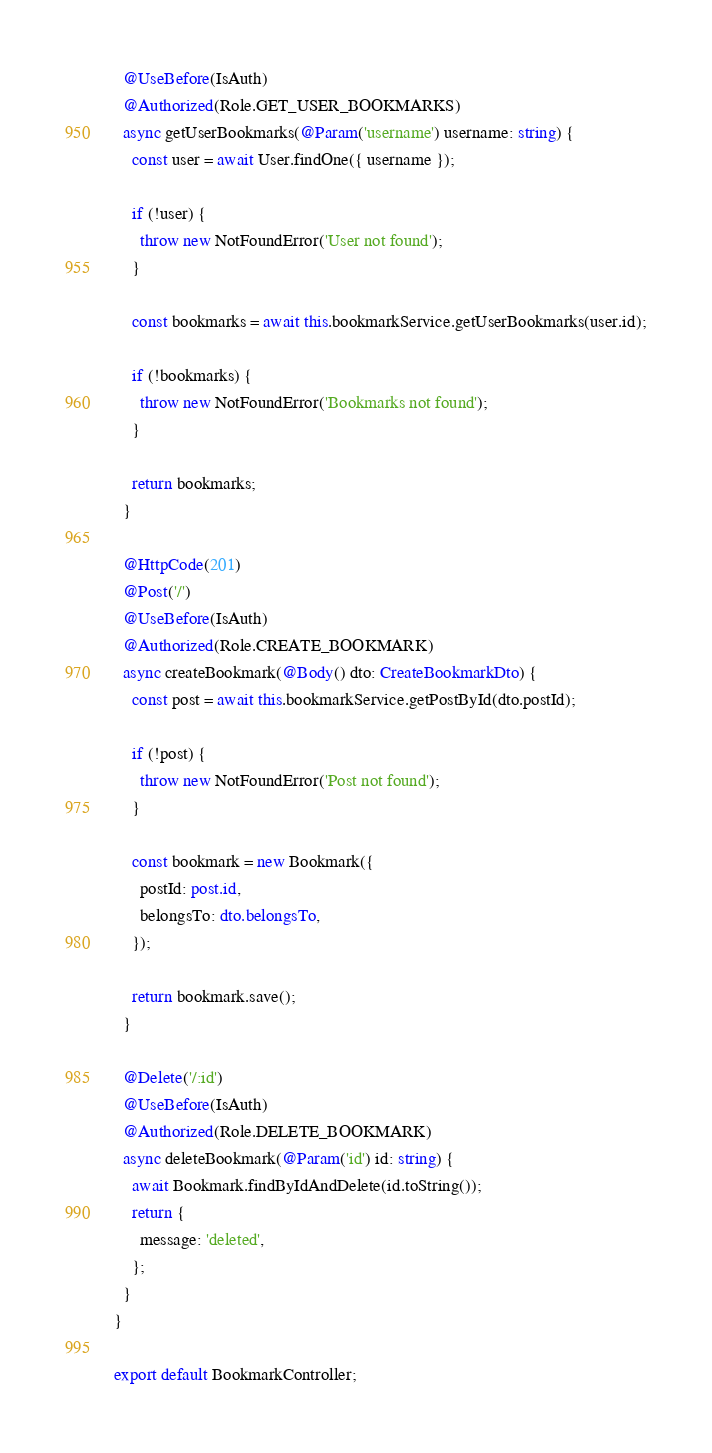<code> <loc_0><loc_0><loc_500><loc_500><_TypeScript_>  @UseBefore(IsAuth)
  @Authorized(Role.GET_USER_BOOKMARKS)
  async getUserBookmarks(@Param('username') username: string) {
    const user = await User.findOne({ username });

    if (!user) {
      throw new NotFoundError('User not found');
    }

    const bookmarks = await this.bookmarkService.getUserBookmarks(user.id);

    if (!bookmarks) {
      throw new NotFoundError('Bookmarks not found');
    }

    return bookmarks;
  }

  @HttpCode(201)
  @Post('/')
  @UseBefore(IsAuth)
  @Authorized(Role.CREATE_BOOKMARK)
  async createBookmark(@Body() dto: CreateBookmarkDto) {
    const post = await this.bookmarkService.getPostById(dto.postId);

    if (!post) {
      throw new NotFoundError('Post not found');
    }

    const bookmark = new Bookmark({
      postId: post.id,
      belongsTo: dto.belongsTo,
    });

    return bookmark.save();
  }

  @Delete('/:id')
  @UseBefore(IsAuth)
  @Authorized(Role.DELETE_BOOKMARK)
  async deleteBookmark(@Param('id') id: string) {
    await Bookmark.findByIdAndDelete(id.toString());
    return {
      message: 'deleted',
    };
  }
}

export default BookmarkController;
</code> 